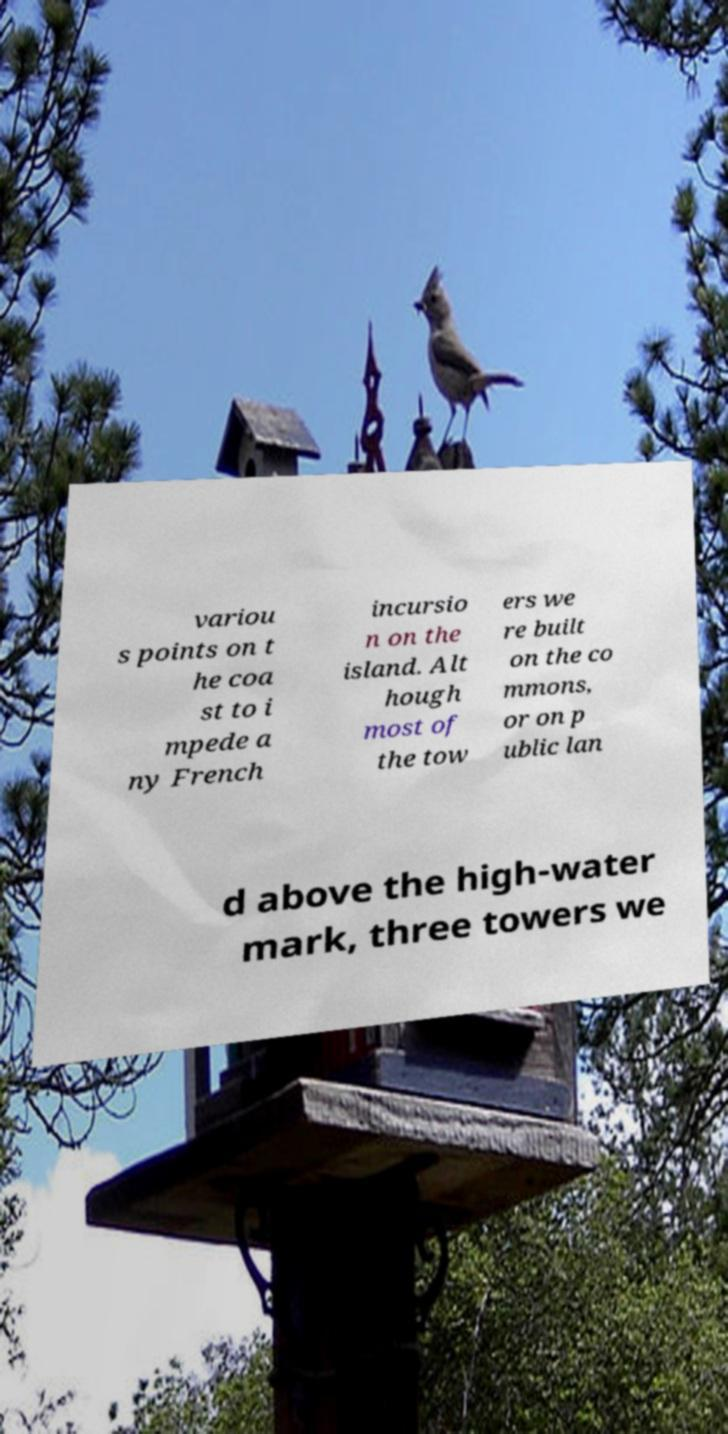There's text embedded in this image that I need extracted. Can you transcribe it verbatim? variou s points on t he coa st to i mpede a ny French incursio n on the island. Alt hough most of the tow ers we re built on the co mmons, or on p ublic lan d above the high-water mark, three towers we 